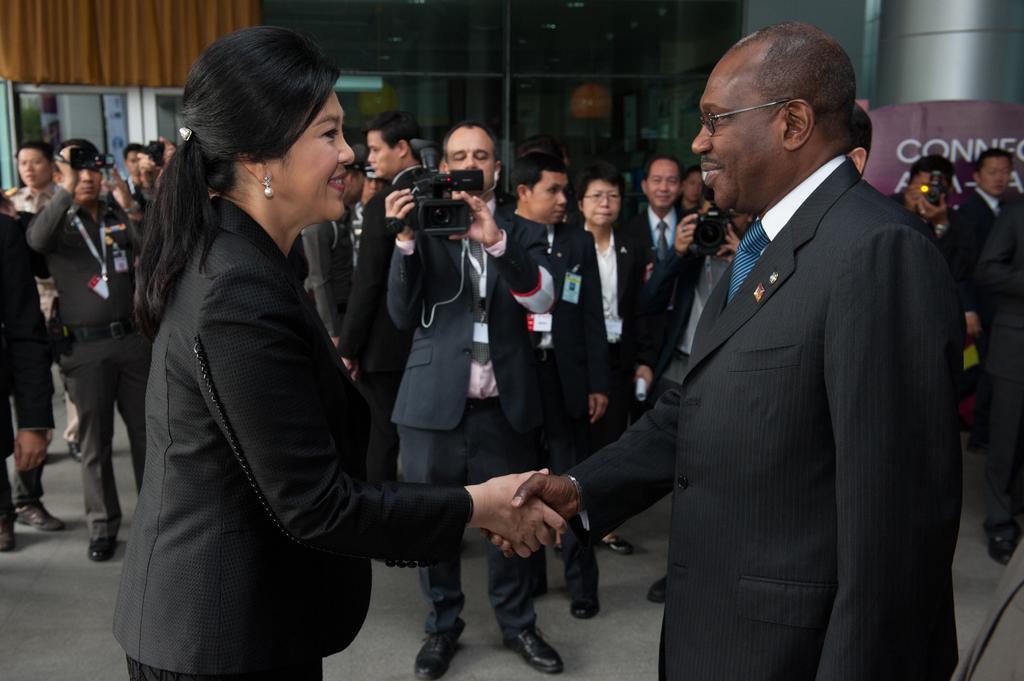Please provide a concise description of this image. In this picture we can see a man and a woman shaking their hands with each other. We can see a few people holding the camera in their hands. There are a few people visible at the back. We can see a cloth in the top left. There is a glass object. Through this glass object, we can see a few things in the background. 